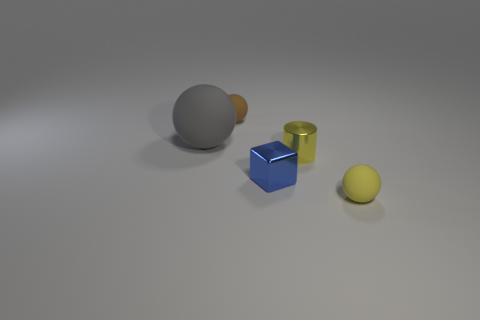Is there anything else that is the same color as the small cylinder?
Offer a terse response. Yes. What number of spheres are large objects or yellow objects?
Provide a succinct answer. 2. What number of things are both behind the blue cube and in front of the big thing?
Your answer should be very brief. 1. Are there the same number of brown objects that are behind the large gray matte thing and tiny yellow objects behind the small cylinder?
Your response must be concise. No. There is a thing that is left of the brown sphere; does it have the same shape as the blue object?
Provide a short and direct response. No. What shape is the small yellow thing behind the matte ball in front of the tiny shiny thing that is left of the tiny metal cylinder?
Offer a terse response. Cylinder. There is a matte object that is the same color as the tiny shiny cylinder; what shape is it?
Provide a succinct answer. Sphere. There is a object that is behind the blue block and right of the tiny brown rubber ball; what is it made of?
Offer a terse response. Metal. Is the number of big cyan matte blocks less than the number of tiny matte things?
Give a very brief answer. Yes. Do the gray matte thing and the small rubber object that is to the left of the small yellow sphere have the same shape?
Give a very brief answer. Yes. 